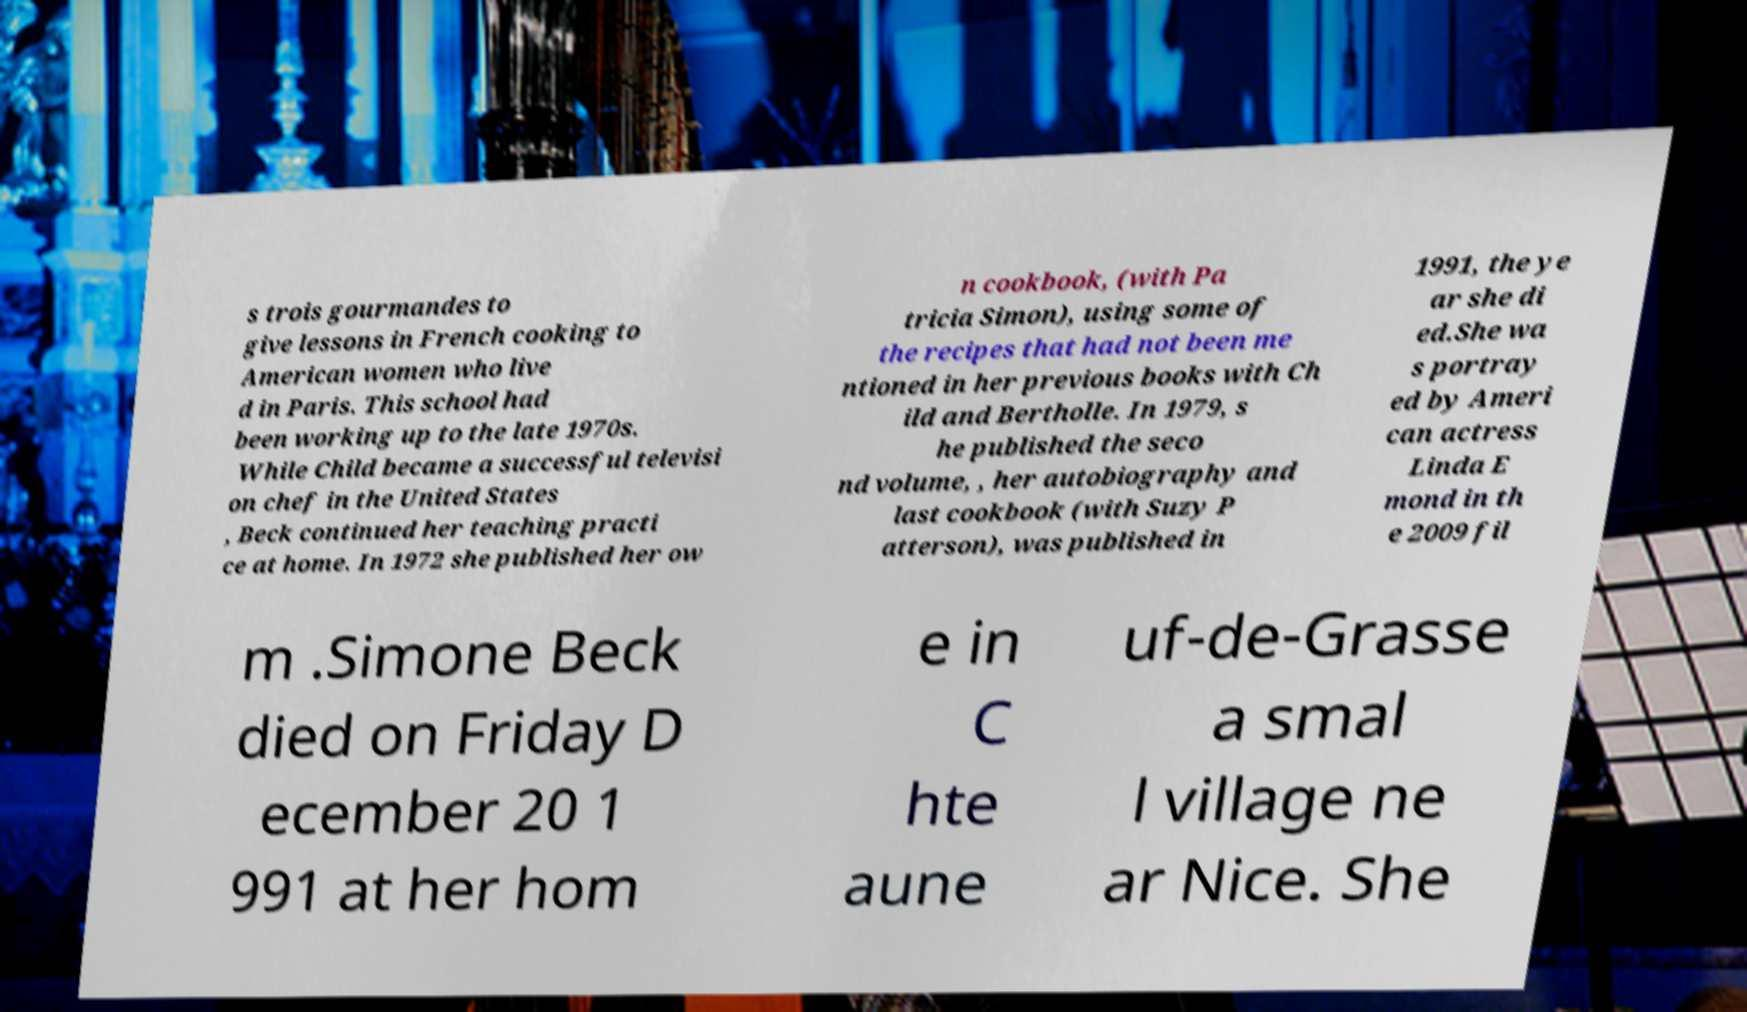What messages or text are displayed in this image? I need them in a readable, typed format. s trois gourmandes to give lessons in French cooking to American women who live d in Paris. This school had been working up to the late 1970s. While Child became a successful televisi on chef in the United States , Beck continued her teaching practi ce at home. In 1972 she published her ow n cookbook, (with Pa tricia Simon), using some of the recipes that had not been me ntioned in her previous books with Ch ild and Bertholle. In 1979, s he published the seco nd volume, , her autobiography and last cookbook (with Suzy P atterson), was published in 1991, the ye ar she di ed.She wa s portray ed by Ameri can actress Linda E mond in th e 2009 fil m .Simone Beck died on Friday D ecember 20 1 991 at her hom e in C hte aune uf-de-Grasse a smal l village ne ar Nice. She 